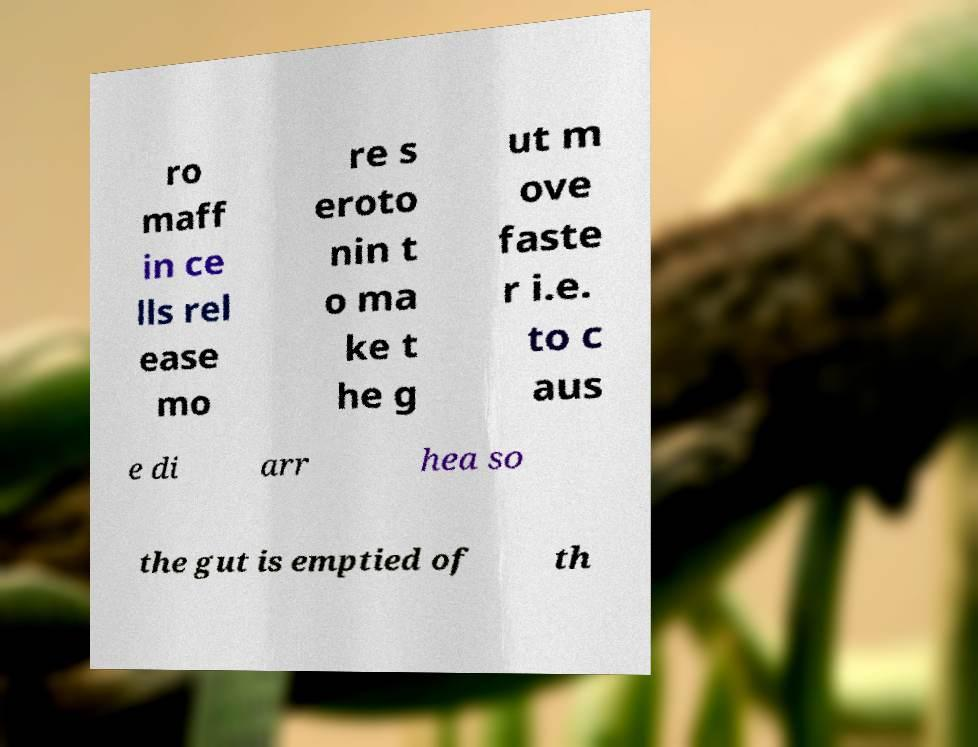Please identify and transcribe the text found in this image. ro maff in ce lls rel ease mo re s eroto nin t o ma ke t he g ut m ove faste r i.e. to c aus e di arr hea so the gut is emptied of th 